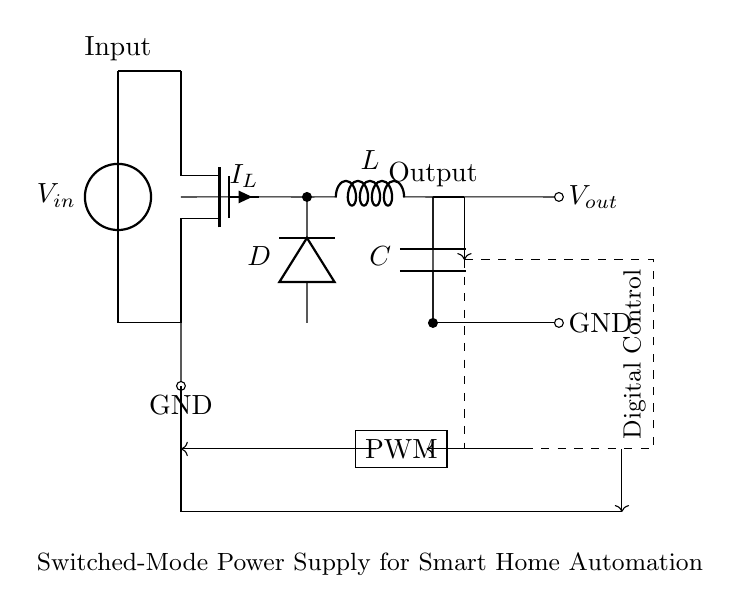What type of transistor is used in this circuit? The circuit diagram shows a Tnmos symbol, indicating that a N-channel MOSFET is being used as the switching element.
Answer: N-channel MOSFET What component is indicated as the output capacitor? In the circuit, the symbol C is used for the capacitor, which is shown connected in parallel with the output load.
Answer: Capacitor What is the function of the PWM block in the circuit? The PWM block modulates the width of the pulses in order to control the output voltage to the connected load through the MOSFET.
Answer: Output control What is the role of the digital control block? The digital control block handles feedback and regulates the PWM signals based on the output voltage in order to maintain a stable voltage.
Answer: Regulation What is the purpose of the inductor in this switched-mode power supply? The inductor L is used to store energy when the MOSFET is on and release it to the output when the MOSFET is off, smoothing the output current.
Answer: Energy storage How is the input voltage connected to the circuit? The input voltage connects to the circuit at the vsource terminal indicated at the top of the diagram, directly supplying power to the MOSFET.
Answer: Directly What type of load is this power supply intended for? The power supply is designed for smart home automation systems, indicating it likely supports low-power electronic devices or sensors.
Answer: Smart home automation systems 